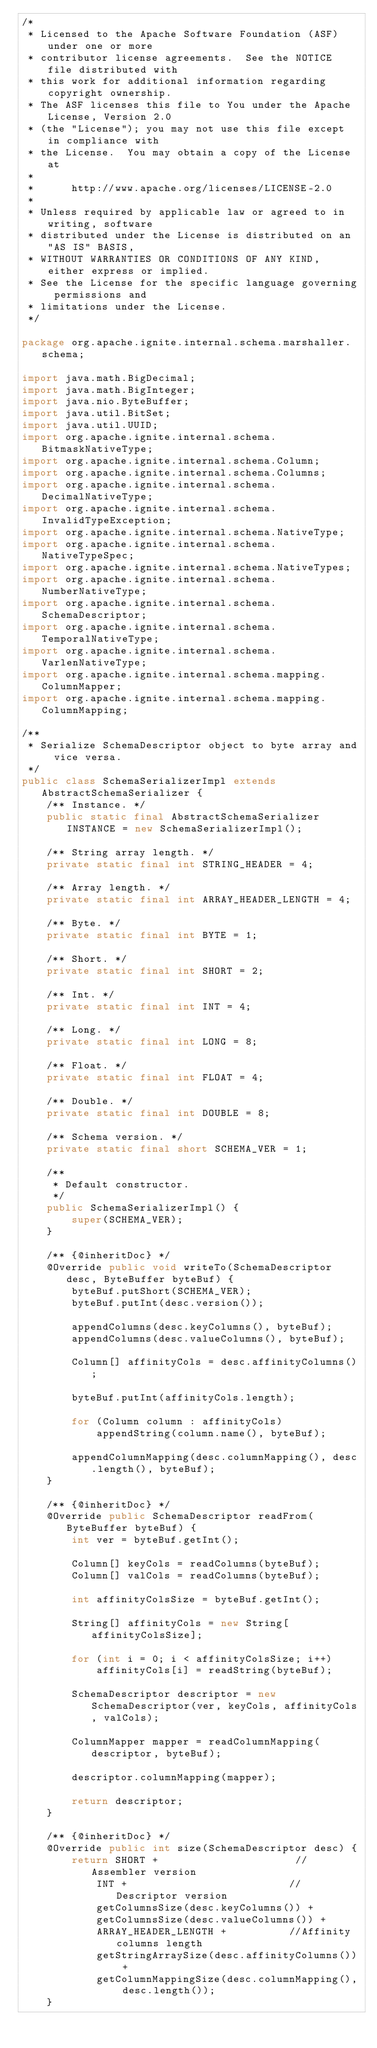Convert code to text. <code><loc_0><loc_0><loc_500><loc_500><_Java_>/*
 * Licensed to the Apache Software Foundation (ASF) under one or more
 * contributor license agreements.  See the NOTICE file distributed with
 * this work for additional information regarding copyright ownership.
 * The ASF licenses this file to You under the Apache License, Version 2.0
 * (the "License"); you may not use this file except in compliance with
 * the License.  You may obtain a copy of the License at
 *
 *      http://www.apache.org/licenses/LICENSE-2.0
 *
 * Unless required by applicable law or agreed to in writing, software
 * distributed under the License is distributed on an "AS IS" BASIS,
 * WITHOUT WARRANTIES OR CONDITIONS OF ANY KIND, either express or implied.
 * See the License for the specific language governing permissions and
 * limitations under the License.
 */

package org.apache.ignite.internal.schema.marshaller.schema;

import java.math.BigDecimal;
import java.math.BigInteger;
import java.nio.ByteBuffer;
import java.util.BitSet;
import java.util.UUID;
import org.apache.ignite.internal.schema.BitmaskNativeType;
import org.apache.ignite.internal.schema.Column;
import org.apache.ignite.internal.schema.Columns;
import org.apache.ignite.internal.schema.DecimalNativeType;
import org.apache.ignite.internal.schema.InvalidTypeException;
import org.apache.ignite.internal.schema.NativeType;
import org.apache.ignite.internal.schema.NativeTypeSpec;
import org.apache.ignite.internal.schema.NativeTypes;
import org.apache.ignite.internal.schema.NumberNativeType;
import org.apache.ignite.internal.schema.SchemaDescriptor;
import org.apache.ignite.internal.schema.TemporalNativeType;
import org.apache.ignite.internal.schema.VarlenNativeType;
import org.apache.ignite.internal.schema.mapping.ColumnMapper;
import org.apache.ignite.internal.schema.mapping.ColumnMapping;

/**
 * Serialize SchemaDescriptor object to byte array and vice versa.
 */
public class SchemaSerializerImpl extends AbstractSchemaSerializer {
    /** Instance. */
    public static final AbstractSchemaSerializer INSTANCE = new SchemaSerializerImpl();

    /** String array length. */
    private static final int STRING_HEADER = 4;

    /** Array length. */
    private static final int ARRAY_HEADER_LENGTH = 4;

    /** Byte. */
    private static final int BYTE = 1;

    /** Short. */
    private static final int SHORT = 2;

    /** Int. */
    private static final int INT = 4;

    /** Long. */
    private static final int LONG = 8;

    /** Float. */
    private static final int FLOAT = 4;

    /** Double. */
    private static final int DOUBLE = 8;

    /** Schema version. */
    private static final short SCHEMA_VER = 1;

    /**
     * Default constructor.
     */
    public SchemaSerializerImpl() {
        super(SCHEMA_VER);
    }

    /** {@inheritDoc} */
    @Override public void writeTo(SchemaDescriptor desc, ByteBuffer byteBuf) {
        byteBuf.putShort(SCHEMA_VER);
        byteBuf.putInt(desc.version());

        appendColumns(desc.keyColumns(), byteBuf);
        appendColumns(desc.valueColumns(), byteBuf);

        Column[] affinityCols = desc.affinityColumns();

        byteBuf.putInt(affinityCols.length);

        for (Column column : affinityCols)
            appendString(column.name(), byteBuf);

        appendColumnMapping(desc.columnMapping(), desc.length(), byteBuf);
    }

    /** {@inheritDoc} */
    @Override public SchemaDescriptor readFrom(ByteBuffer byteBuf) {
        int ver = byteBuf.getInt();

        Column[] keyCols = readColumns(byteBuf);
        Column[] valCols = readColumns(byteBuf);

        int affinityColsSize = byteBuf.getInt();

        String[] affinityCols = new String[affinityColsSize];

        for (int i = 0; i < affinityColsSize; i++)
            affinityCols[i] = readString(byteBuf);

        SchemaDescriptor descriptor = new SchemaDescriptor(ver, keyCols, affinityCols, valCols);

        ColumnMapper mapper = readColumnMapping(descriptor, byteBuf);

        descriptor.columnMapping(mapper);

        return descriptor;
    }

    /** {@inheritDoc} */
    @Override public int size(SchemaDescriptor desc) {
        return SHORT +                      //Assembler version
            INT +                          //Descriptor version
            getColumnsSize(desc.keyColumns()) +
            getColumnsSize(desc.valueColumns()) +
            ARRAY_HEADER_LENGTH +          //Affinity columns length
            getStringArraySize(desc.affinityColumns()) +
            getColumnMappingSize(desc.columnMapping(), desc.length());
    }
</code> 